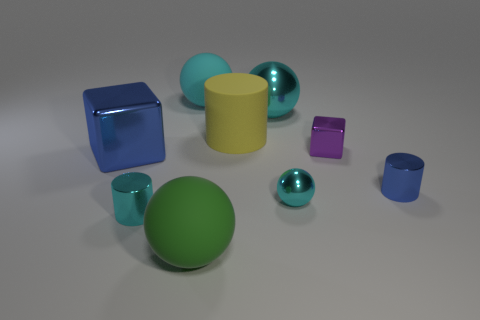Subtract all yellow cubes. How many cyan spheres are left? 3 Add 1 green spheres. How many objects exist? 10 Subtract all cylinders. How many objects are left? 6 Subtract all red cubes. Subtract all purple blocks. How many objects are left? 8 Add 6 large cyan metal things. How many large cyan metal things are left? 7 Add 6 big green matte things. How many big green matte things exist? 7 Subtract 0 green cylinders. How many objects are left? 9 